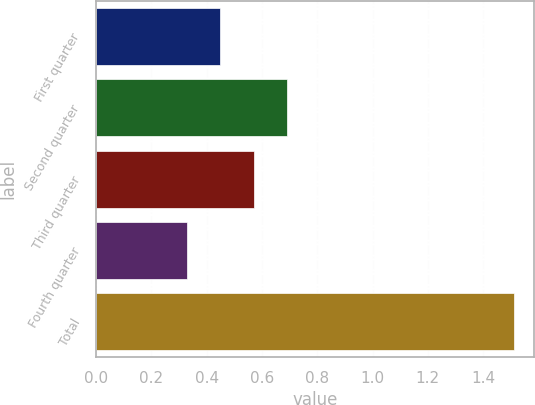Convert chart to OTSL. <chart><loc_0><loc_0><loc_500><loc_500><bar_chart><fcel>First quarter<fcel>Second quarter<fcel>Third quarter<fcel>Fourth quarter<fcel>Total<nl><fcel>0.45<fcel>0.69<fcel>0.57<fcel>0.33<fcel>1.51<nl></chart> 